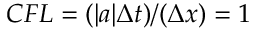<formula> <loc_0><loc_0><loc_500><loc_500>C F L = ( | a | \Delta t ) / ( \Delta x ) = 1</formula> 